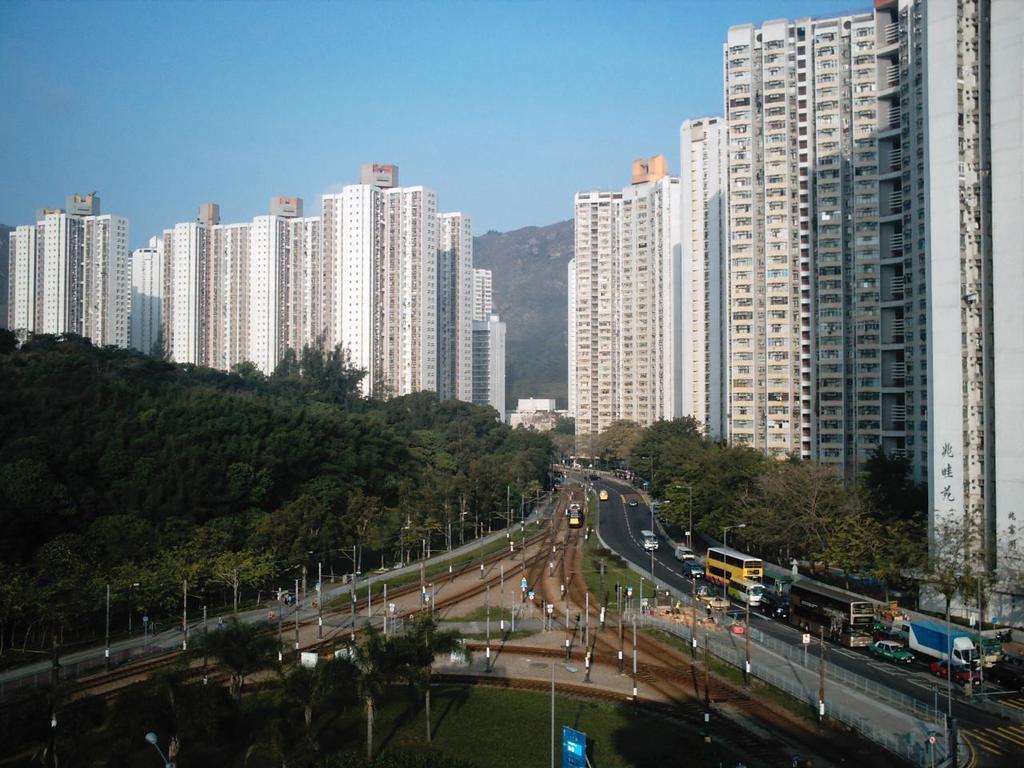Can you describe this image briefly? In this image we can see some poles, railway track, road on which there are some vehicles moving and there are some trees and buildings on left and right side of the image and in the background of the image there is mountain and clear sky. 